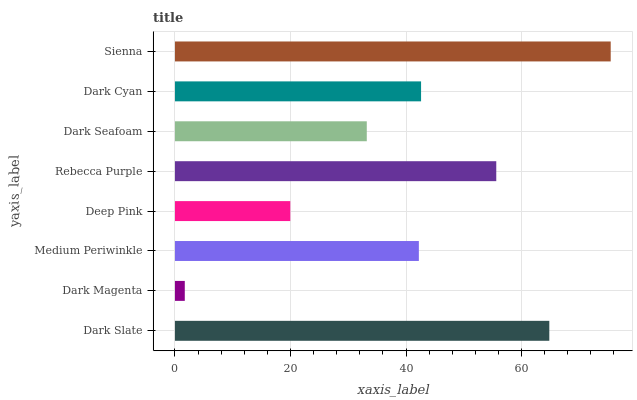Is Dark Magenta the minimum?
Answer yes or no. Yes. Is Sienna the maximum?
Answer yes or no. Yes. Is Medium Periwinkle the minimum?
Answer yes or no. No. Is Medium Periwinkle the maximum?
Answer yes or no. No. Is Medium Periwinkle greater than Dark Magenta?
Answer yes or no. Yes. Is Dark Magenta less than Medium Periwinkle?
Answer yes or no. Yes. Is Dark Magenta greater than Medium Periwinkle?
Answer yes or no. No. Is Medium Periwinkle less than Dark Magenta?
Answer yes or no. No. Is Dark Cyan the high median?
Answer yes or no. Yes. Is Medium Periwinkle the low median?
Answer yes or no. Yes. Is Dark Slate the high median?
Answer yes or no. No. Is Dark Magenta the low median?
Answer yes or no. No. 